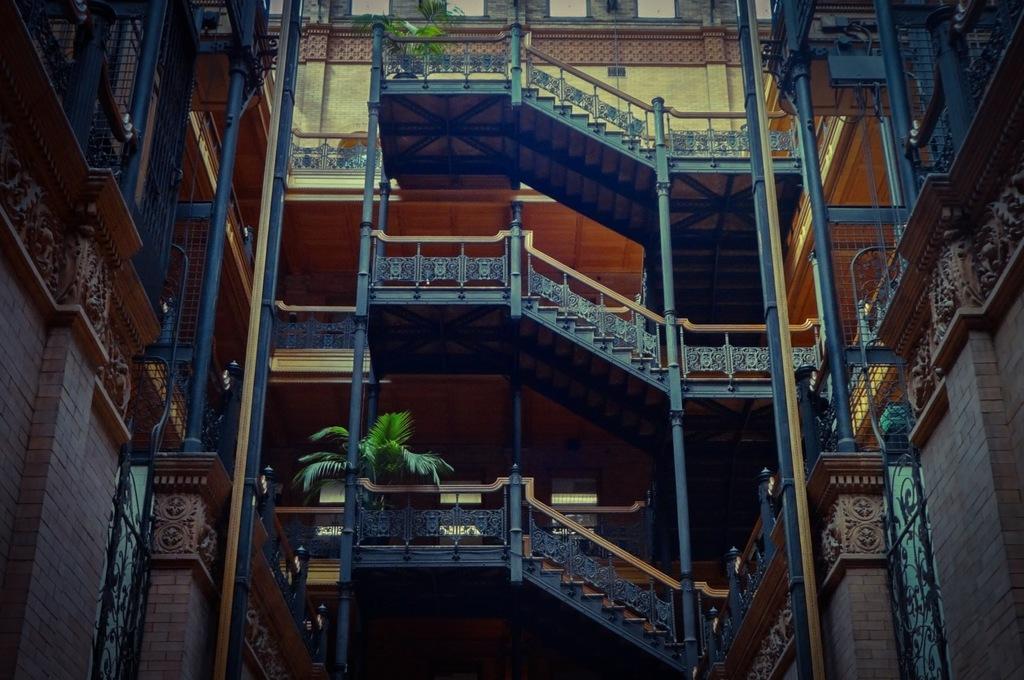Describe this image in one or two sentences. This picture shows a tall building and we see stars and couple of plants. 